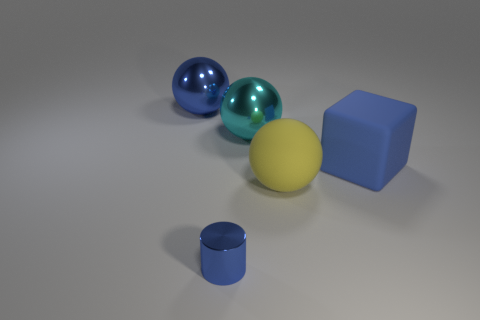Is there anything else that is the same size as the blue metal cylinder?
Provide a succinct answer. No. Are there any other things that have the same shape as the big blue matte object?
Make the answer very short. No. What is the shape of the blue metallic thing that is the same size as the cyan metallic thing?
Make the answer very short. Sphere. Is there a cyan shiny object of the same shape as the large yellow object?
Your answer should be very brief. Yes. Are the blue cylinder and the ball on the left side of the small blue metallic cylinder made of the same material?
Offer a terse response. Yes. Are there any small metal cylinders that have the same color as the large cube?
Give a very brief answer. Yes. What number of other things are the same material as the cyan ball?
Offer a very short reply. 2. There is a big rubber block; does it have the same color as the shiny ball that is left of the metal cylinder?
Make the answer very short. Yes. Are there more big objects right of the small thing than tiny blue rubber balls?
Make the answer very short. Yes. There is a big shiny thing that is behind the large metal ball that is right of the tiny metal cylinder; how many large yellow matte objects are to the left of it?
Make the answer very short. 0. 